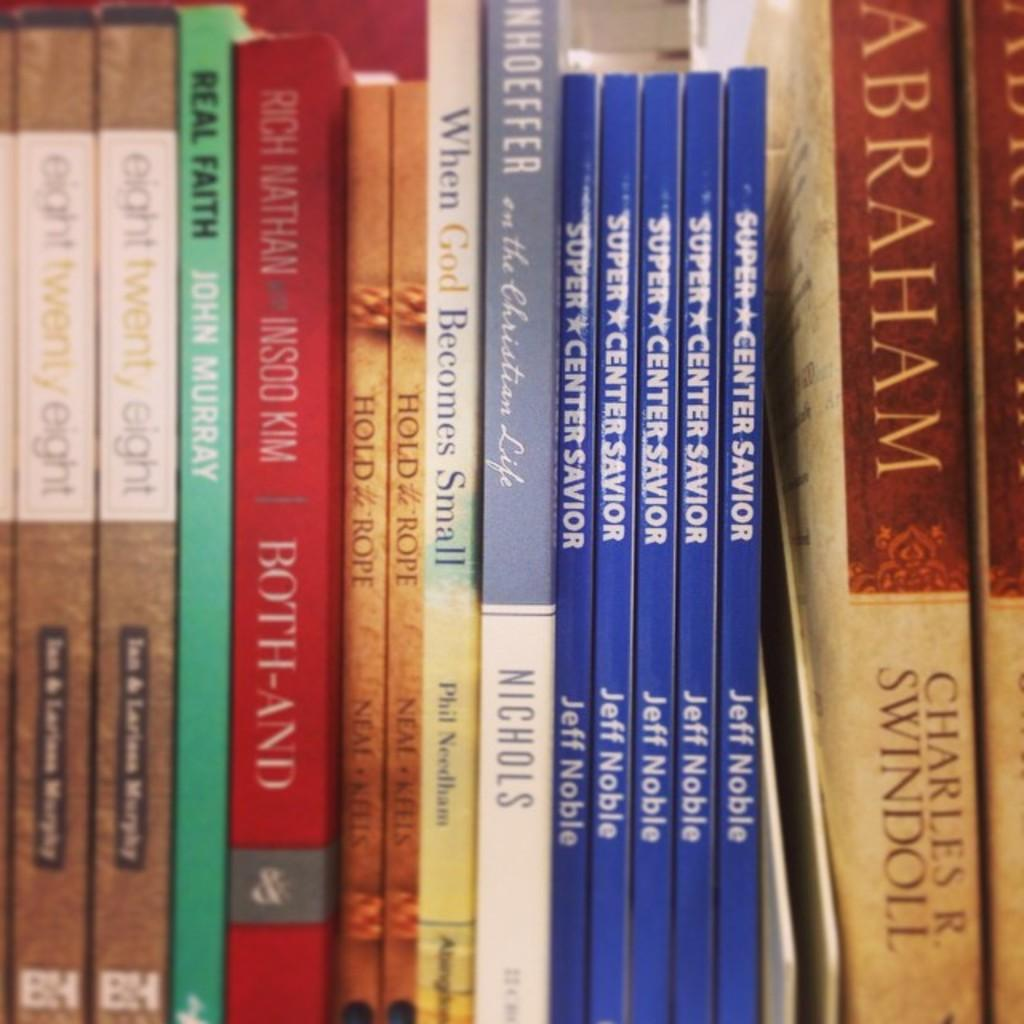<image>
Share a concise interpretation of the image provided. Several books, including one titled "When God Becomes Small," are lined up. 